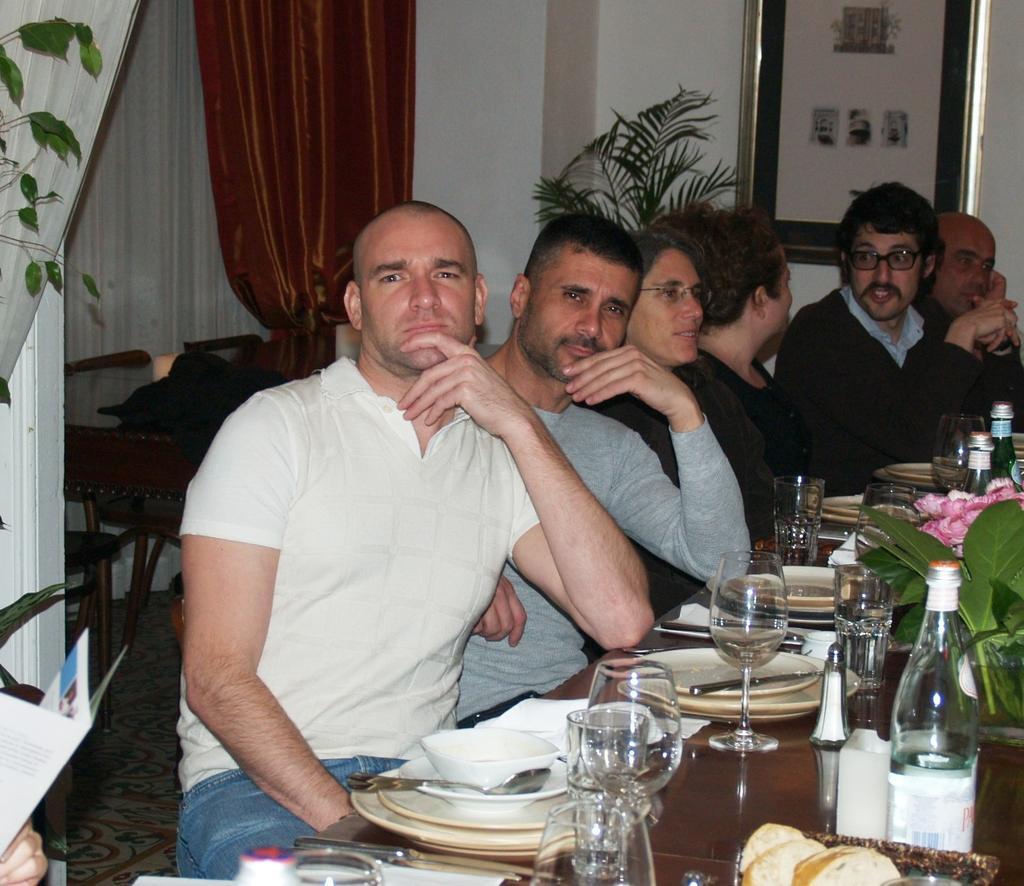Could you give a brief overview of what you see in this image? As we can see in the image there is a wall, photo frame, curtain, few people sitting on chairs and tables. On tables there are plates, bowls and bottles. 